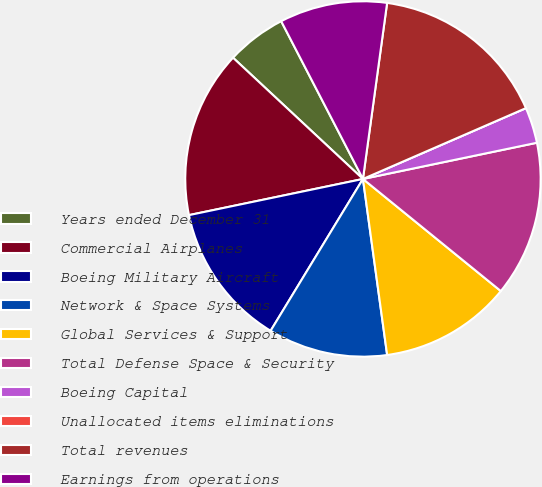Convert chart to OTSL. <chart><loc_0><loc_0><loc_500><loc_500><pie_chart><fcel>Years ended December 31<fcel>Commercial Airplanes<fcel>Boeing Military Aircraft<fcel>Network & Space Systems<fcel>Global Services & Support<fcel>Total Defense Space & Security<fcel>Boeing Capital<fcel>Unallocated items eliminations<fcel>Total revenues<fcel>Earnings from operations<nl><fcel>5.44%<fcel>15.21%<fcel>13.04%<fcel>10.87%<fcel>11.96%<fcel>14.13%<fcel>3.26%<fcel>0.0%<fcel>16.3%<fcel>9.78%<nl></chart> 